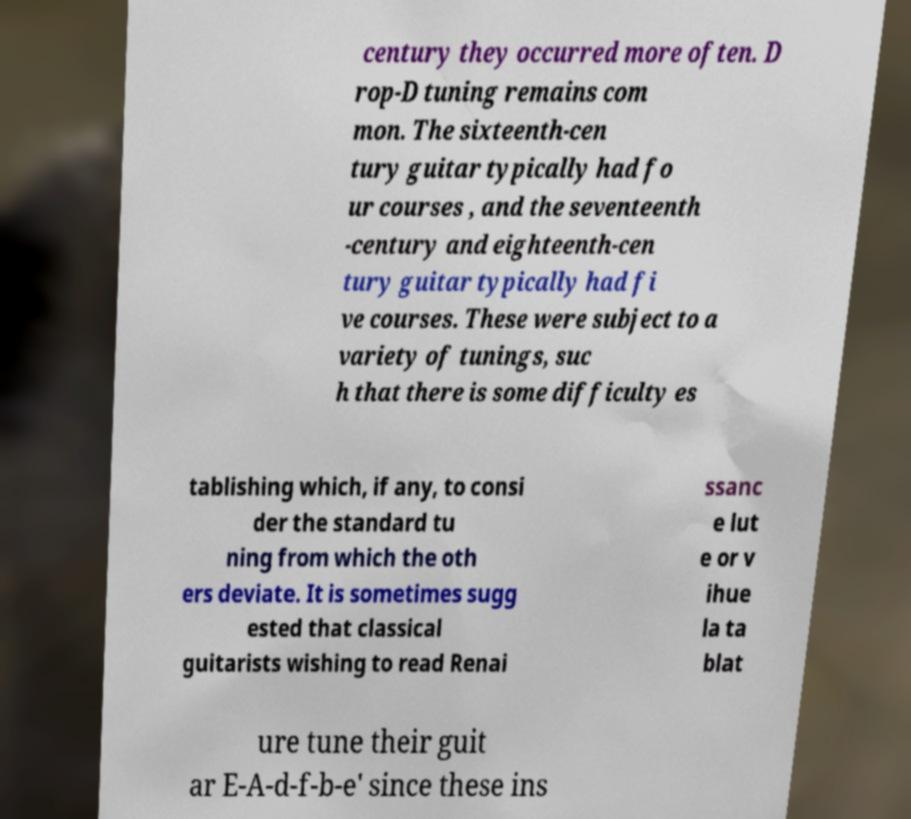Could you extract and type out the text from this image? century they occurred more often. D rop-D tuning remains com mon. The sixteenth-cen tury guitar typically had fo ur courses , and the seventeenth -century and eighteenth-cen tury guitar typically had fi ve courses. These were subject to a variety of tunings, suc h that there is some difficulty es tablishing which, if any, to consi der the standard tu ning from which the oth ers deviate. It is sometimes sugg ested that classical guitarists wishing to read Renai ssanc e lut e or v ihue la ta blat ure tune their guit ar E-A-d-f-b-e' since these ins 